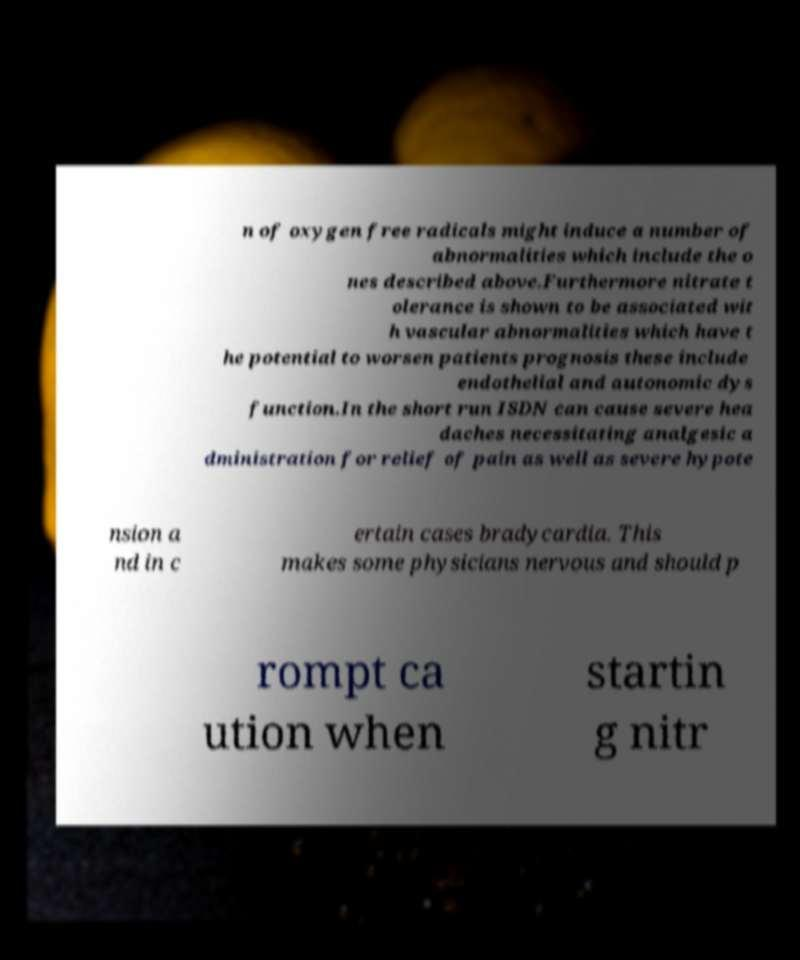Please read and relay the text visible in this image. What does it say? n of oxygen free radicals might induce a number of abnormalities which include the o nes described above.Furthermore nitrate t olerance is shown to be associated wit h vascular abnormalities which have t he potential to worsen patients prognosis these include endothelial and autonomic dys function.In the short run ISDN can cause severe hea daches necessitating analgesic a dministration for relief of pain as well as severe hypote nsion a nd in c ertain cases bradycardia. This makes some physicians nervous and should p rompt ca ution when startin g nitr 